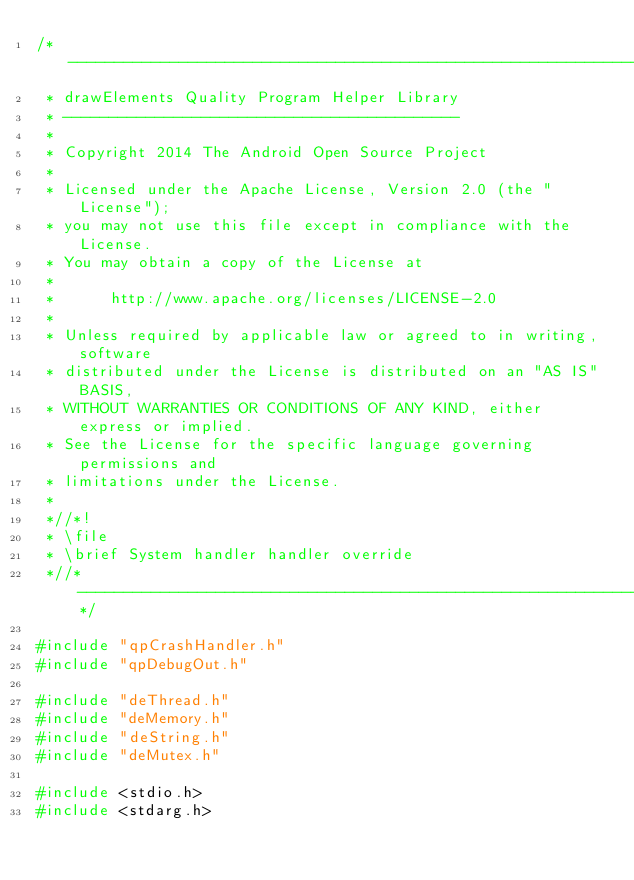Convert code to text. <code><loc_0><loc_0><loc_500><loc_500><_C_>/*-------------------------------------------------------------------------
 * drawElements Quality Program Helper Library
 * -------------------------------------------
 *
 * Copyright 2014 The Android Open Source Project
 *
 * Licensed under the Apache License, Version 2.0 (the "License");
 * you may not use this file except in compliance with the License.
 * You may obtain a copy of the License at
 *
 *      http://www.apache.org/licenses/LICENSE-2.0
 *
 * Unless required by applicable law or agreed to in writing, software
 * distributed under the License is distributed on an "AS IS" BASIS,
 * WITHOUT WARRANTIES OR CONDITIONS OF ANY KIND, either express or implied.
 * See the License for the specific language governing permissions and
 * limitations under the License.
 *
 *//*!
 * \file
 * \brief System handler handler override
 *//*--------------------------------------------------------------------*/

#include "qpCrashHandler.h"
#include "qpDebugOut.h"

#include "deThread.h"
#include "deMemory.h"
#include "deString.h"
#include "deMutex.h"

#include <stdio.h>
#include <stdarg.h>
</code> 